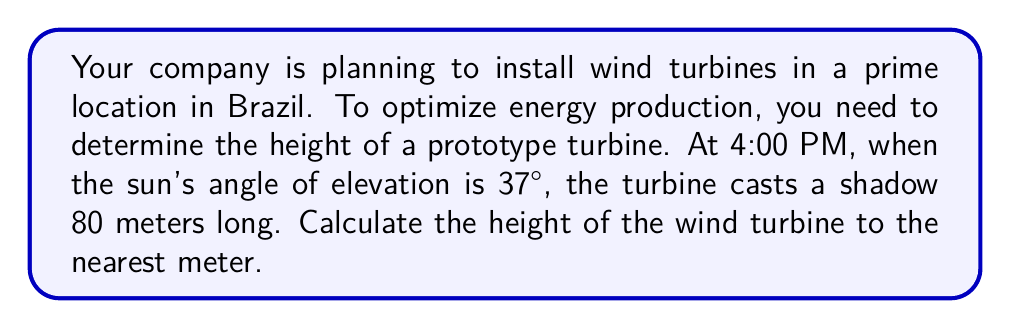Teach me how to tackle this problem. Let's approach this step-by-step using trigonometric ratios:

1) We can use the tangent ratio to solve this problem. The tangent of an angle in a right triangle is the ratio of the opposite side to the adjacent side.

2) In this case:
   - The angle of elevation (sun's angle) is 37°
   - The adjacent side is the length of the shadow (80 meters)
   - The opposite side is the height of the turbine (what we're solving for)

3) Let's call the height of the turbine $h$. We can write the tangent ratio as:

   $$\tan(37°) = \frac{h}{80}$$

4) To solve for $h$, we multiply both sides by 80:

   $$h = 80 \tan(37°)$$

5) Now, let's calculate:
   
   $$h = 80 \times \tan(37°)$$
   $$h = 80 \times 0.7535$$
   $$h = 60.28$$

6) Rounding to the nearest meter:

   $$h \approx 60 \text{ meters}$$

Therefore, the height of the wind turbine is approximately 60 meters.
Answer: 60 meters 